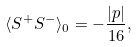<formula> <loc_0><loc_0><loc_500><loc_500>\langle S ^ { + } S ^ { - } \rangle _ { 0 } = - \frac { \left | p \right | } { 1 6 } ,</formula> 